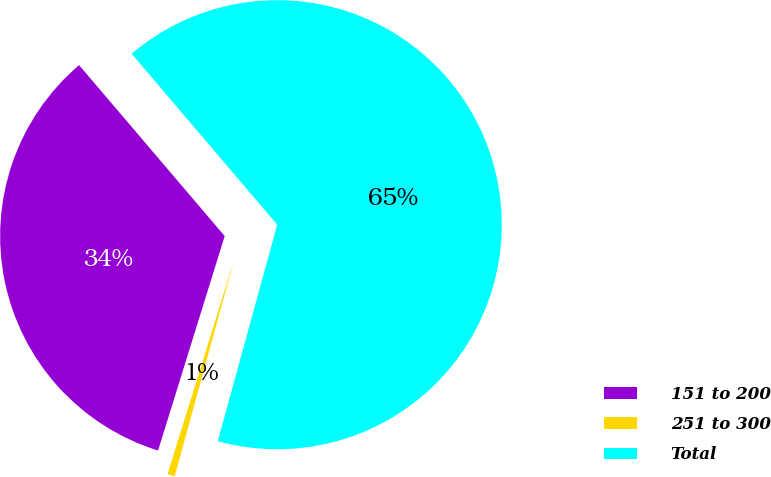Convert chart to OTSL. <chart><loc_0><loc_0><loc_500><loc_500><pie_chart><fcel>151 to 200<fcel>251 to 300<fcel>Total<nl><fcel>33.98%<fcel>0.53%<fcel>65.5%<nl></chart> 